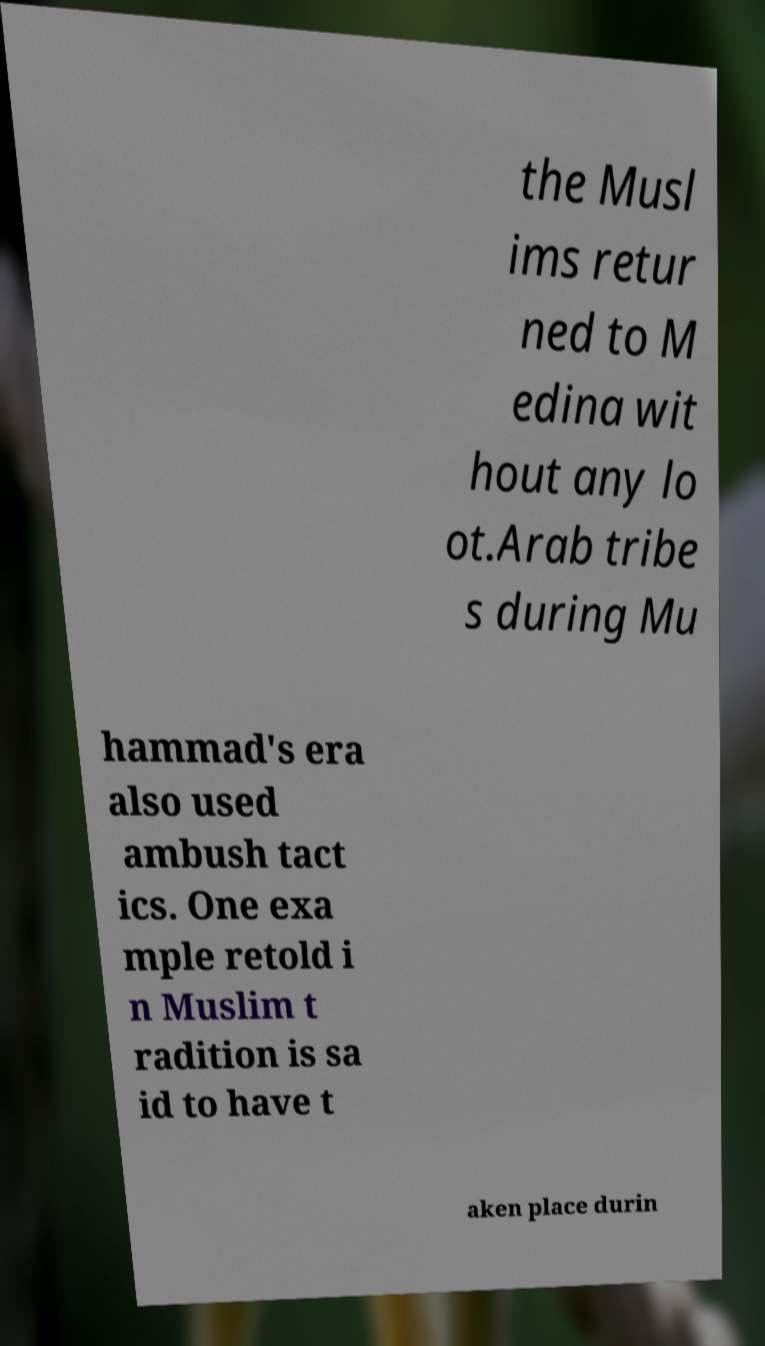There's text embedded in this image that I need extracted. Can you transcribe it verbatim? the Musl ims retur ned to M edina wit hout any lo ot.Arab tribe s during Mu hammad's era also used ambush tact ics. One exa mple retold i n Muslim t radition is sa id to have t aken place durin 